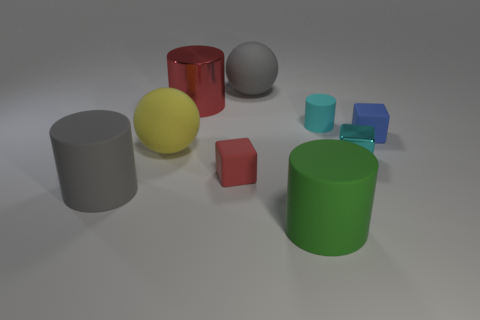Are there any other things that have the same size as the red matte block?
Make the answer very short. Yes. How many other objects are the same shape as the small red thing?
Keep it short and to the point. 2. Is the cyan block the same size as the blue cube?
Your answer should be very brief. Yes. Are any large rubber cylinders visible?
Your answer should be compact. Yes. Is there any other thing that is the same material as the blue object?
Provide a short and direct response. Yes. Are there any red cubes that have the same material as the big green cylinder?
Make the answer very short. Yes. There is a yellow object that is the same size as the red shiny thing; what is its material?
Offer a terse response. Rubber. What number of small cyan rubber objects have the same shape as the green matte thing?
Provide a succinct answer. 1. What is the size of the thing that is made of the same material as the small cyan block?
Provide a succinct answer. Large. What material is the large thing that is both left of the large gray sphere and in front of the yellow matte ball?
Keep it short and to the point. Rubber. 